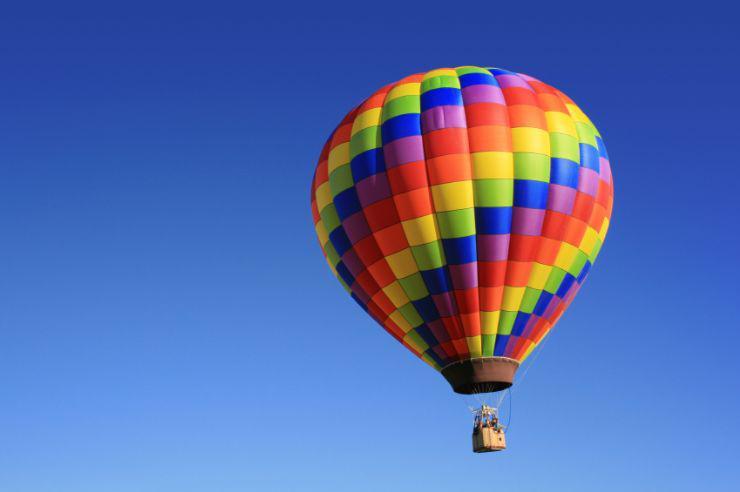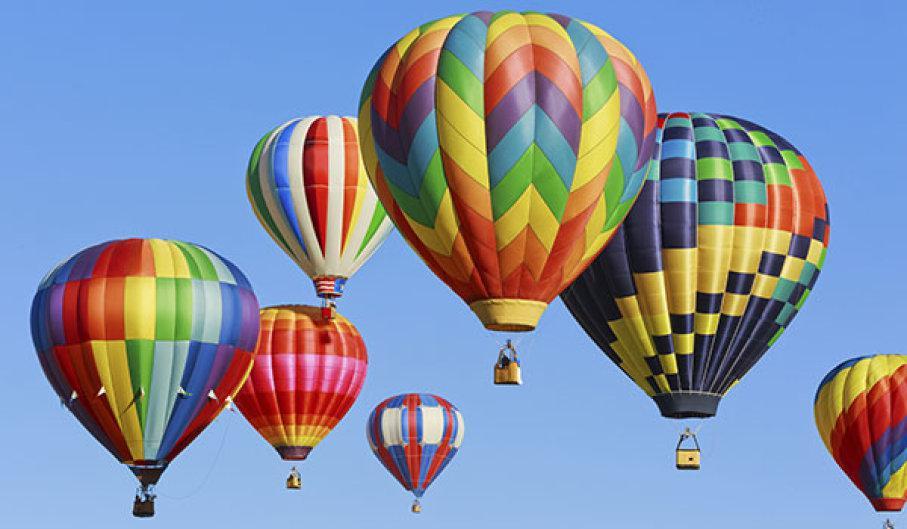The first image is the image on the left, the second image is the image on the right. Considering the images on both sides, is "An image shows just one multi-colored balloon against a cloudless sky." valid? Answer yes or no. Yes. The first image is the image on the left, the second image is the image on the right. Evaluate the accuracy of this statement regarding the images: "there are exactly seven balloons in the image on the right". Is it true? Answer yes or no. Yes. 